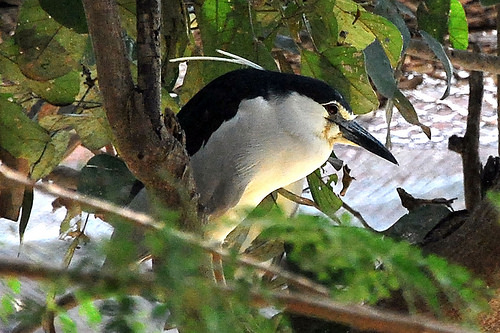<image>
Is there a bird under the branch? No. The bird is not positioned under the branch. The vertical relationship between these objects is different. Is there a bird on the leaf? Yes. Looking at the image, I can see the bird is positioned on top of the leaf, with the leaf providing support. 